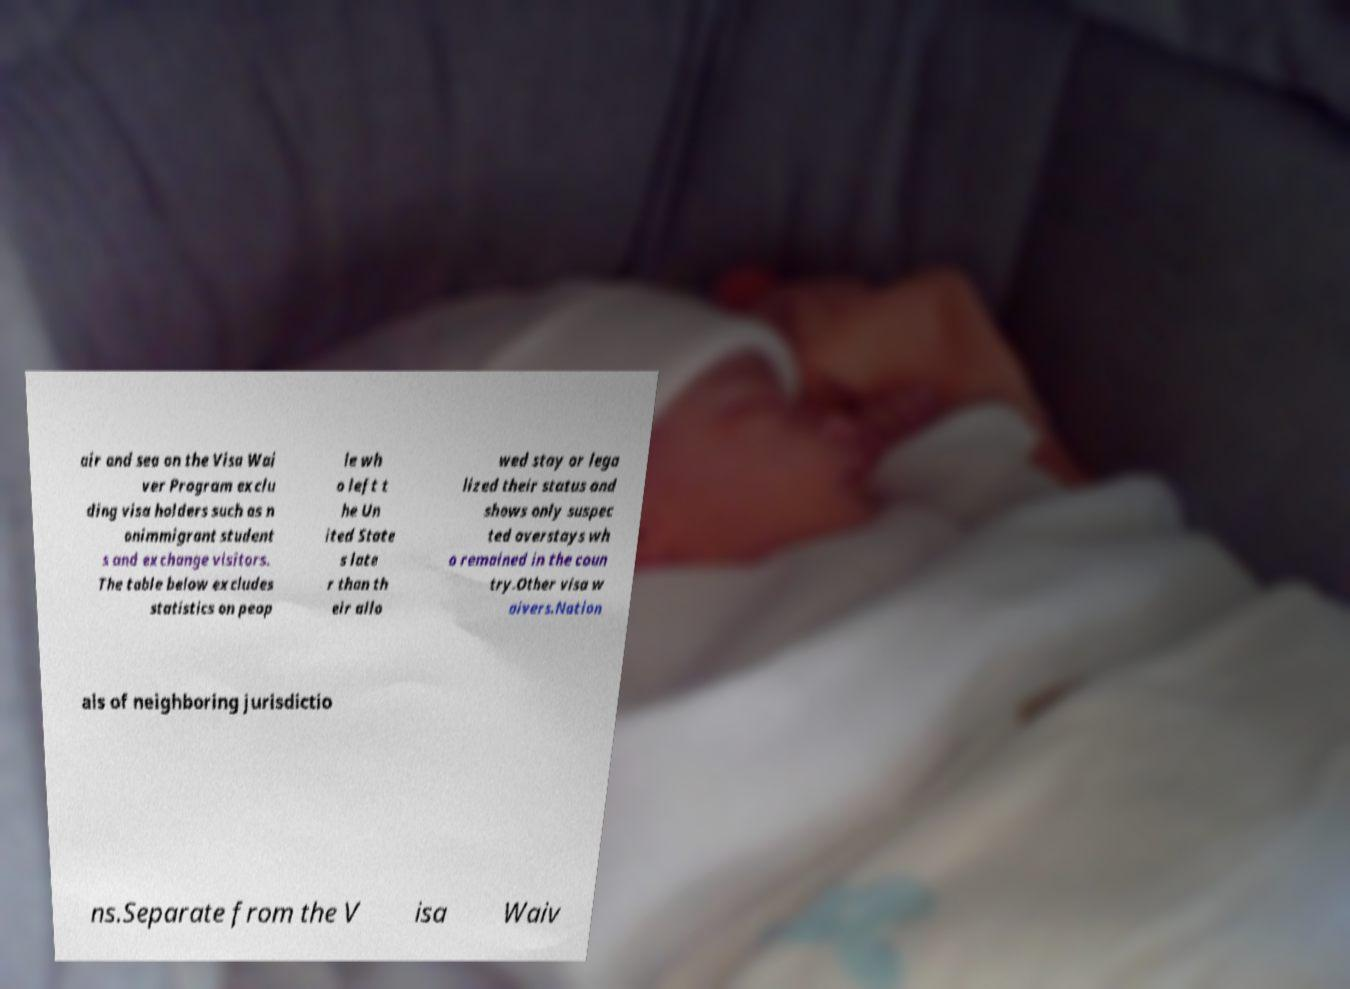There's text embedded in this image that I need extracted. Can you transcribe it verbatim? air and sea on the Visa Wai ver Program exclu ding visa holders such as n onimmigrant student s and exchange visitors. The table below excludes statistics on peop le wh o left t he Un ited State s late r than th eir allo wed stay or lega lized their status and shows only suspec ted overstays wh o remained in the coun try.Other visa w aivers.Nation als of neighboring jurisdictio ns.Separate from the V isa Waiv 